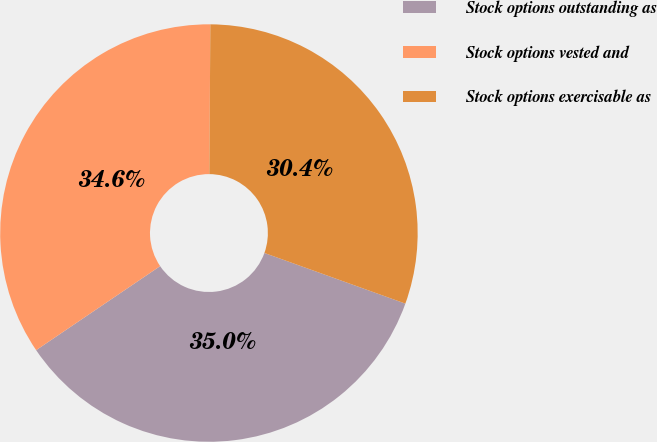Convert chart. <chart><loc_0><loc_0><loc_500><loc_500><pie_chart><fcel>Stock options outstanding as<fcel>Stock options vested and<fcel>Stock options exercisable as<nl><fcel>35.03%<fcel>34.59%<fcel>30.38%<nl></chart> 